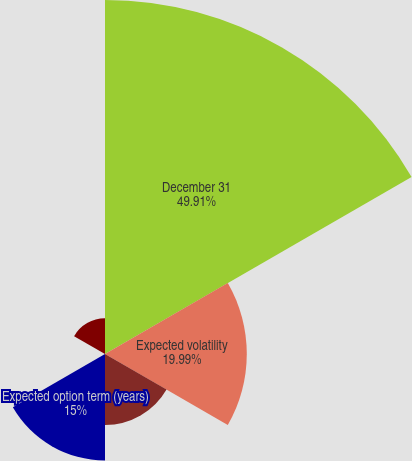Convert chart. <chart><loc_0><loc_0><loc_500><loc_500><pie_chart><fcel>December 31<fcel>Expected volatility<fcel>Expected annual dividend yield<fcel>Expected option term (years)<fcel>Risk-free interest rate<fcel>Fair value at grant date<nl><fcel>49.91%<fcel>19.99%<fcel>10.02%<fcel>15.0%<fcel>0.05%<fcel>5.03%<nl></chart> 